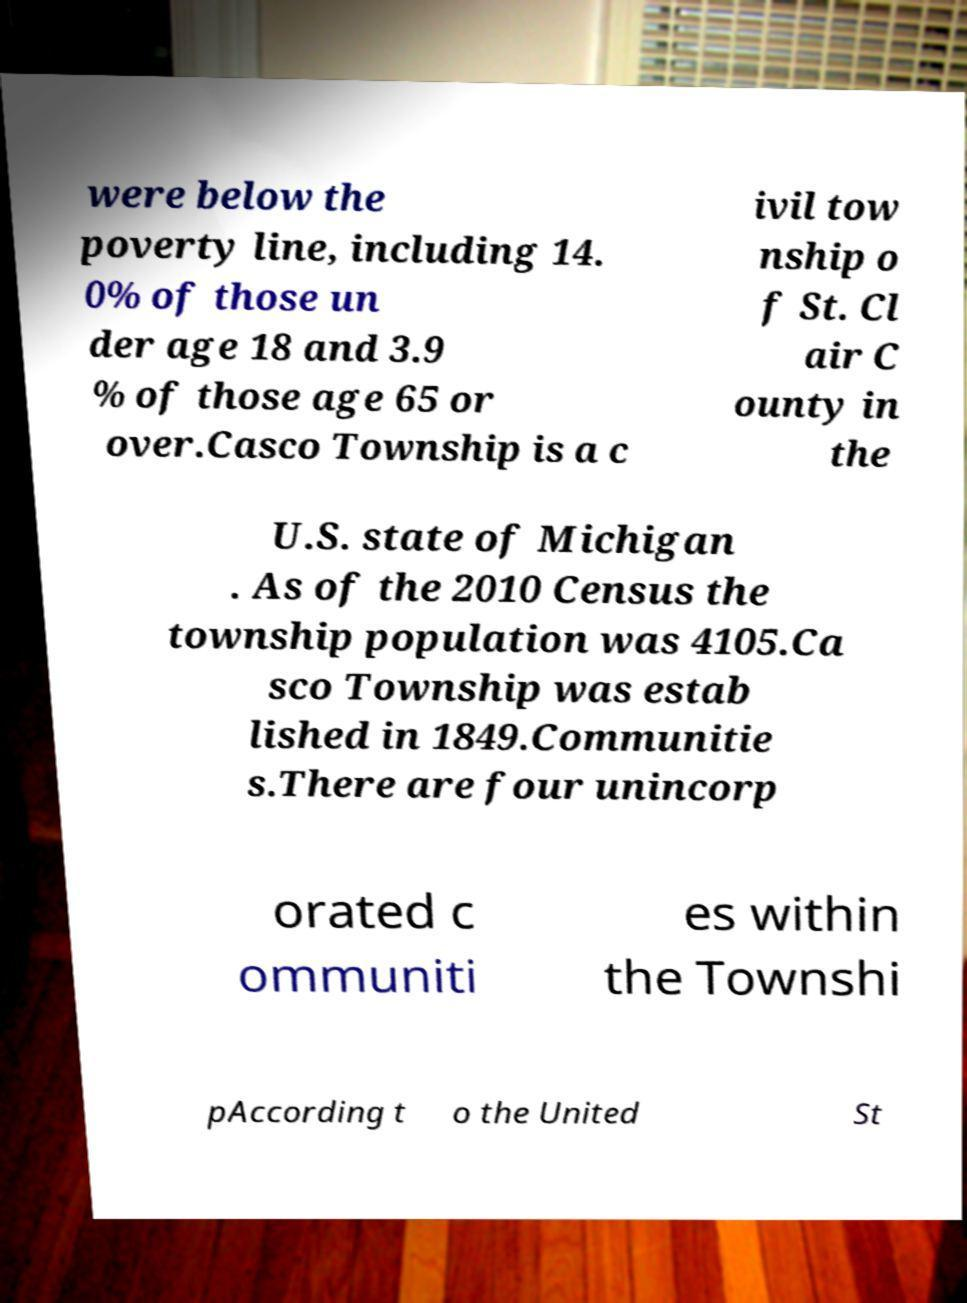What messages or text are displayed in this image? I need them in a readable, typed format. were below the poverty line, including 14. 0% of those un der age 18 and 3.9 % of those age 65 or over.Casco Township is a c ivil tow nship o f St. Cl air C ounty in the U.S. state of Michigan . As of the 2010 Census the township population was 4105.Ca sco Township was estab lished in 1849.Communitie s.There are four unincorp orated c ommuniti es within the Townshi pAccording t o the United St 